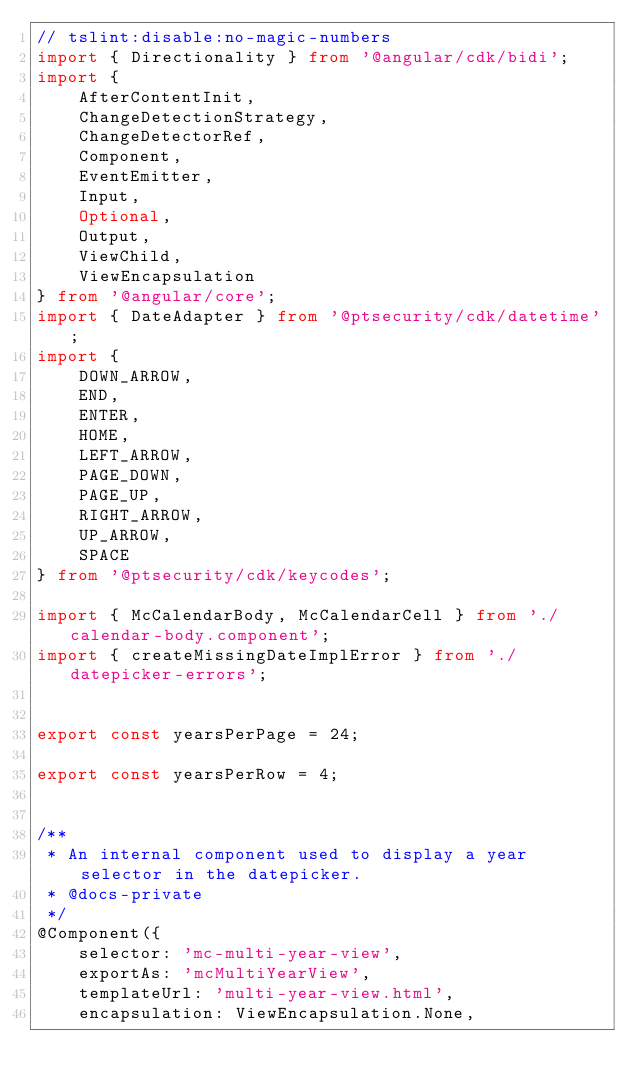Convert code to text. <code><loc_0><loc_0><loc_500><loc_500><_TypeScript_>// tslint:disable:no-magic-numbers
import { Directionality } from '@angular/cdk/bidi';
import {
    AfterContentInit,
    ChangeDetectionStrategy,
    ChangeDetectorRef,
    Component,
    EventEmitter,
    Input,
    Optional,
    Output,
    ViewChild,
    ViewEncapsulation
} from '@angular/core';
import { DateAdapter } from '@ptsecurity/cdk/datetime';
import {
    DOWN_ARROW,
    END,
    ENTER,
    HOME,
    LEFT_ARROW,
    PAGE_DOWN,
    PAGE_UP,
    RIGHT_ARROW,
    UP_ARROW,
    SPACE
} from '@ptsecurity/cdk/keycodes';

import { McCalendarBody, McCalendarCell } from './calendar-body.component';
import { createMissingDateImplError } from './datepicker-errors';


export const yearsPerPage = 24;

export const yearsPerRow = 4;


/**
 * An internal component used to display a year selector in the datepicker.
 * @docs-private
 */
@Component({
    selector: 'mc-multi-year-view',
    exportAs: 'mcMultiYearView',
    templateUrl: 'multi-year-view.html',
    encapsulation: ViewEncapsulation.None,</code> 